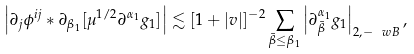Convert formula to latex. <formula><loc_0><loc_0><loc_500><loc_500>\left | \partial _ { j } \phi ^ { i j } * \partial _ { \beta _ { 1 } } [ \mu ^ { 1 / 2 } \partial ^ { \alpha _ { 1 } } g _ { 1 } ] \right | \lesssim [ 1 + | v | ] ^ { - 2 } \sum _ { \bar { \beta } \leq \beta _ { 1 } } \left | \partial _ { \bar { \beta } } ^ { \alpha _ { 1 } } g _ { 1 } \right | _ { 2 , - \ w B } ,</formula> 